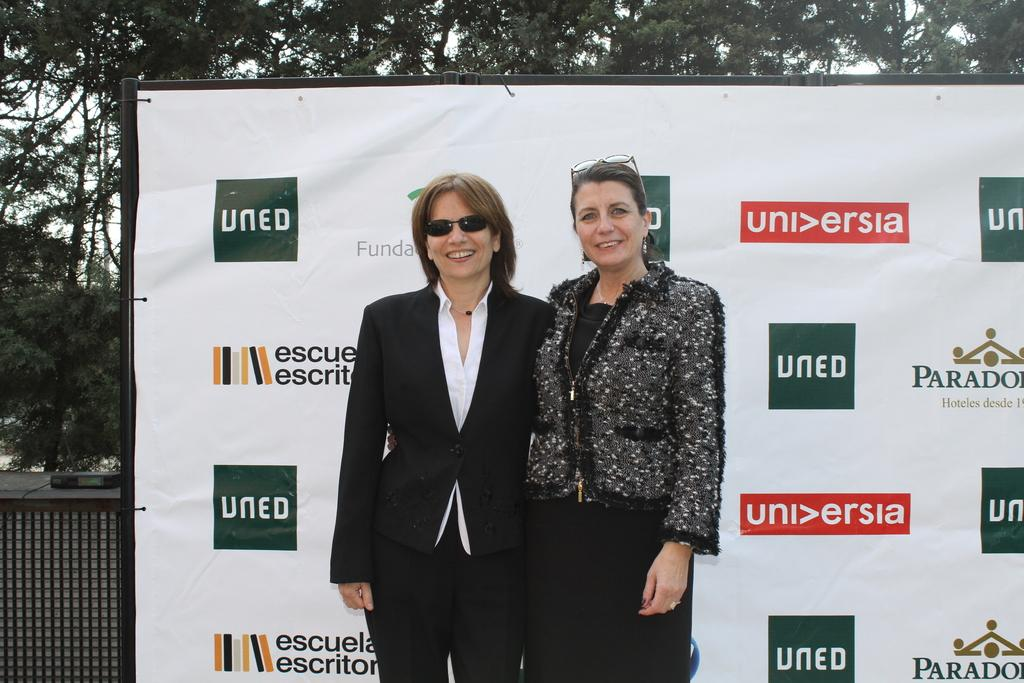How many people are in the image? There are two people standing in the center of the image. What are the people doing in the image? The people are smiling. What can be seen in the background of the image? There is a board and trees in the background of the image. What is visible in the image besides the people and the background? The sky is visible in the image. What type of water can be seen flowing through the bushes in the image? There is no water or bushes present in the image; it features two people standing and smiling, with a board, trees, and the sky visible in the background. 